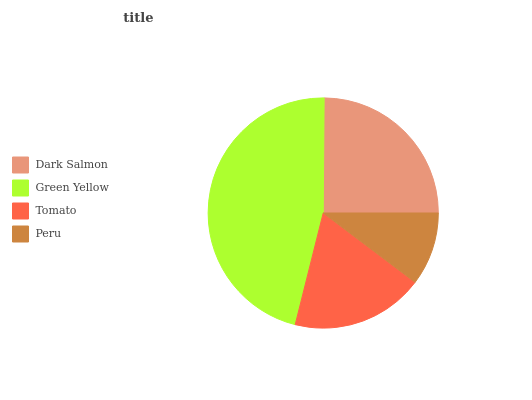Is Peru the minimum?
Answer yes or no. Yes. Is Green Yellow the maximum?
Answer yes or no. Yes. Is Tomato the minimum?
Answer yes or no. No. Is Tomato the maximum?
Answer yes or no. No. Is Green Yellow greater than Tomato?
Answer yes or no. Yes. Is Tomato less than Green Yellow?
Answer yes or no. Yes. Is Tomato greater than Green Yellow?
Answer yes or no. No. Is Green Yellow less than Tomato?
Answer yes or no. No. Is Dark Salmon the high median?
Answer yes or no. Yes. Is Tomato the low median?
Answer yes or no. Yes. Is Tomato the high median?
Answer yes or no. No. Is Peru the low median?
Answer yes or no. No. 